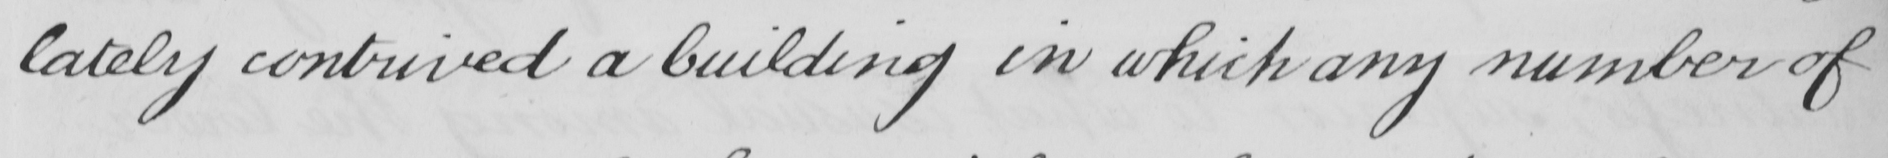Can you read and transcribe this handwriting? lately contrived a building in which any number of 